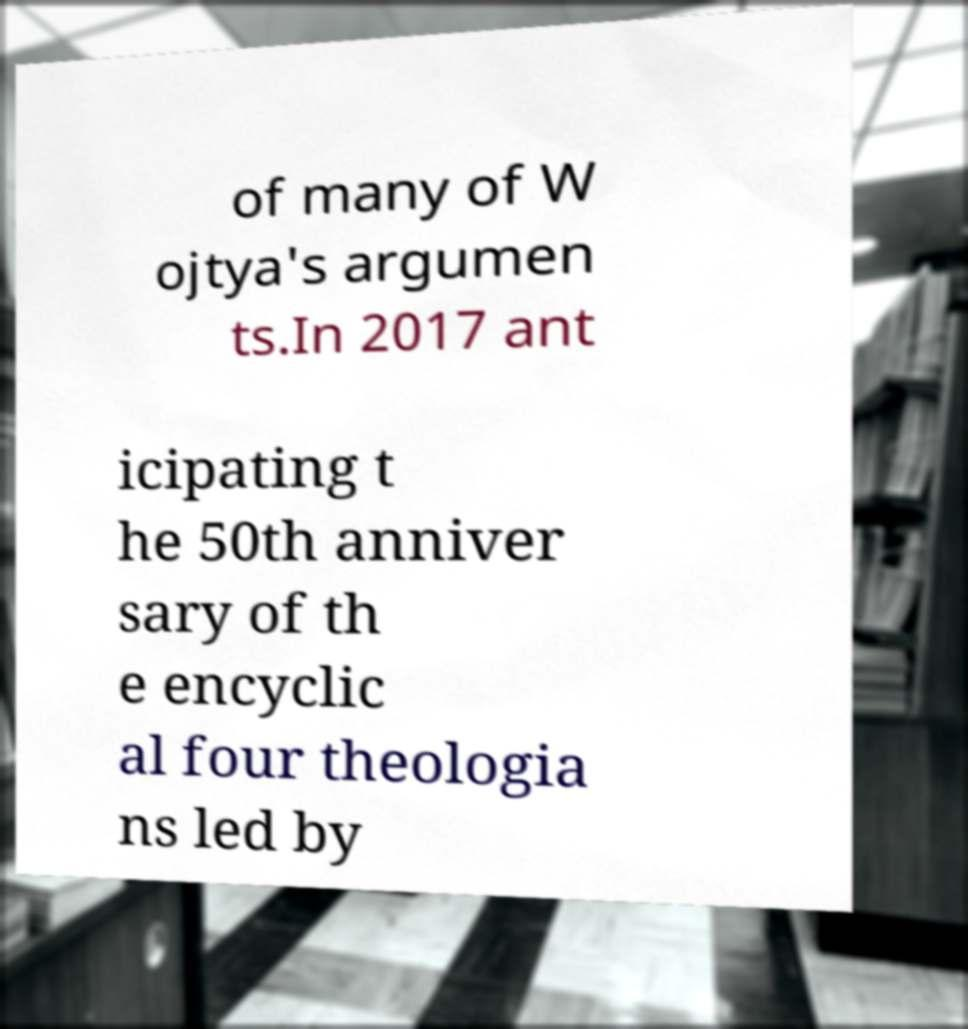There's text embedded in this image that I need extracted. Can you transcribe it verbatim? of many of W ojtya's argumen ts.In 2017 ant icipating t he 50th anniver sary of th e encyclic al four theologia ns led by 